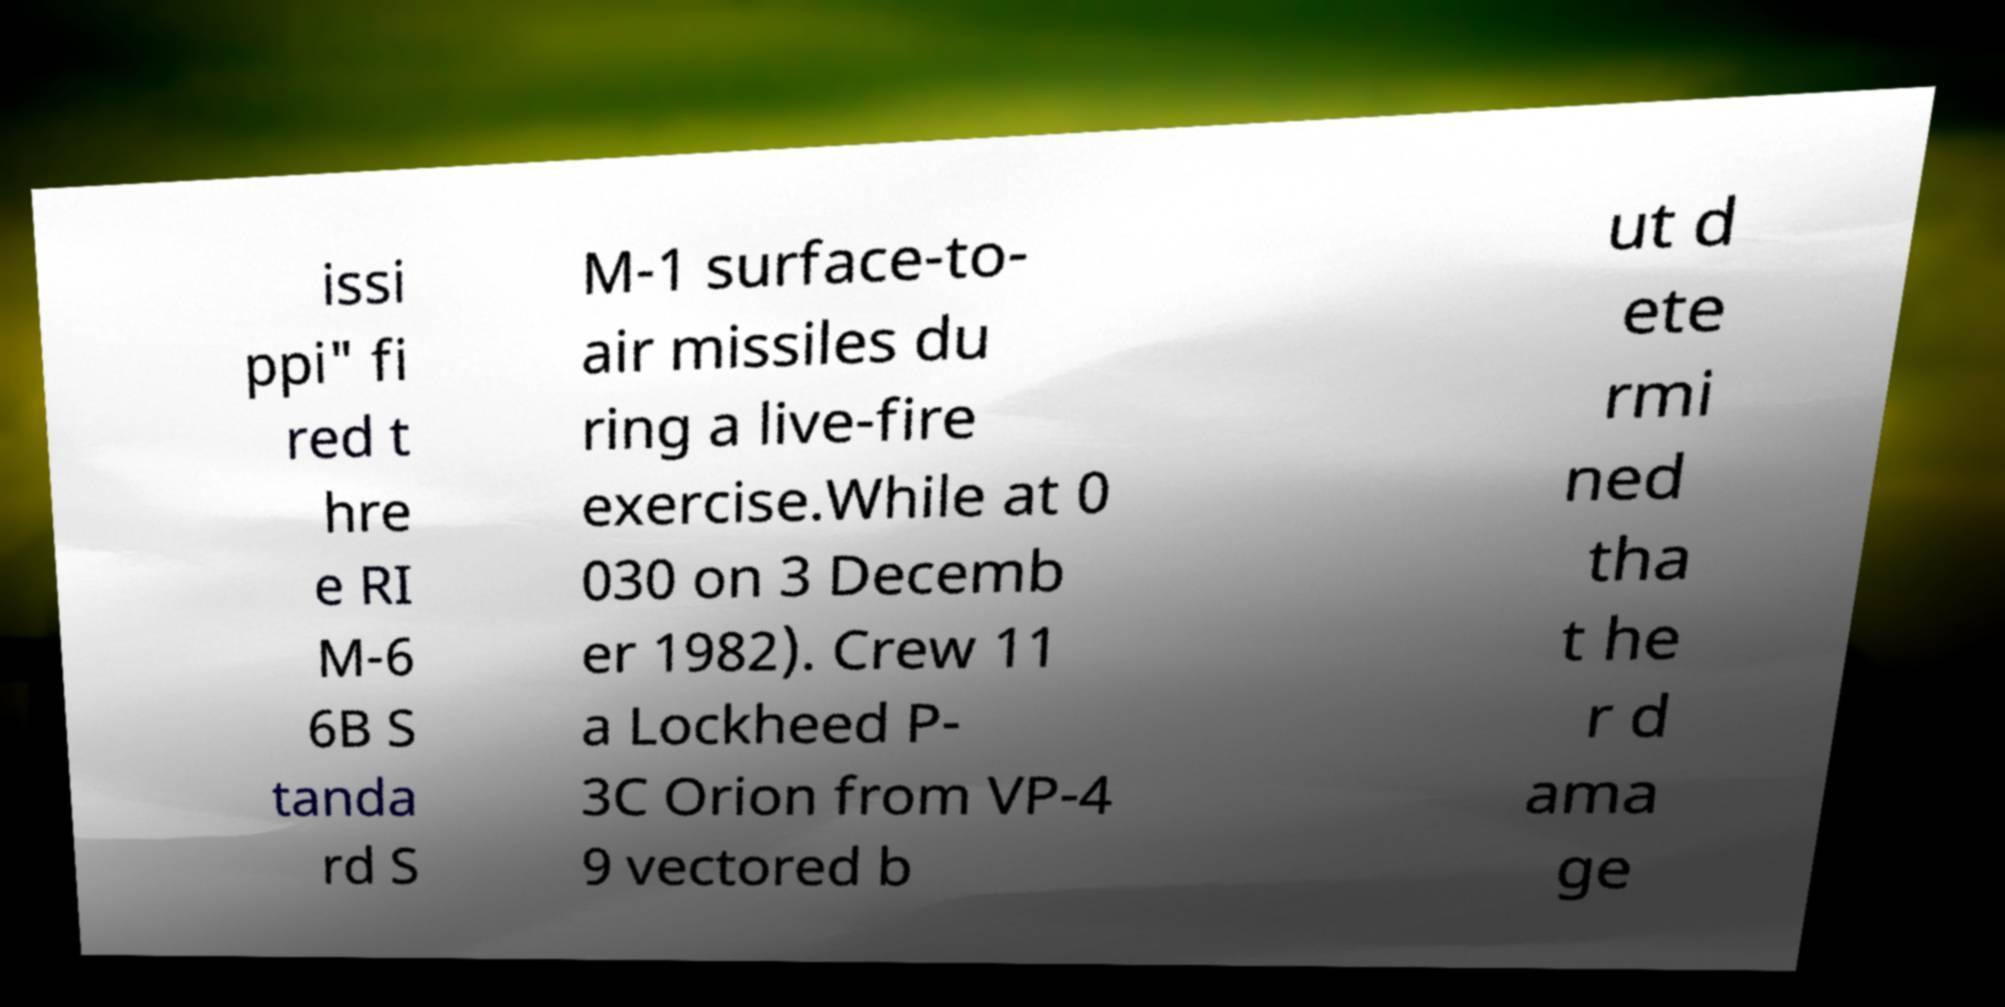Could you assist in decoding the text presented in this image and type it out clearly? issi ppi" fi red t hre e RI M-6 6B S tanda rd S M-1 surface-to- air missiles du ring a live-fire exercise.While at 0 030 on 3 Decemb er 1982). Crew 11 a Lockheed P- 3C Orion from VP-4 9 vectored b ut d ete rmi ned tha t he r d ama ge 